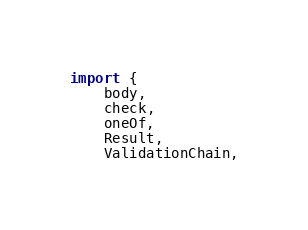Convert code to text. <code><loc_0><loc_0><loc_500><loc_500><_TypeScript_>import {
    body,
    check,
    oneOf,
    Result,
    ValidationChain,</code> 